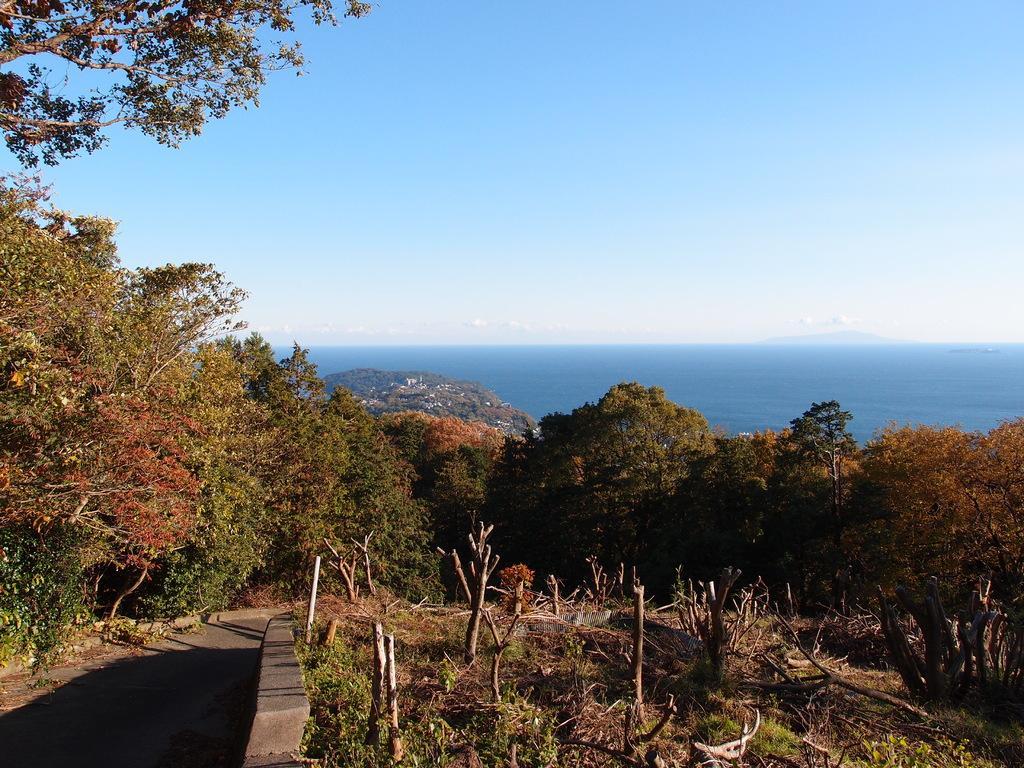Please provide a concise description of this image. In this image we can see trees, beside that we can see the road. And we can see the water, at the top we can see the sky with clouds. 